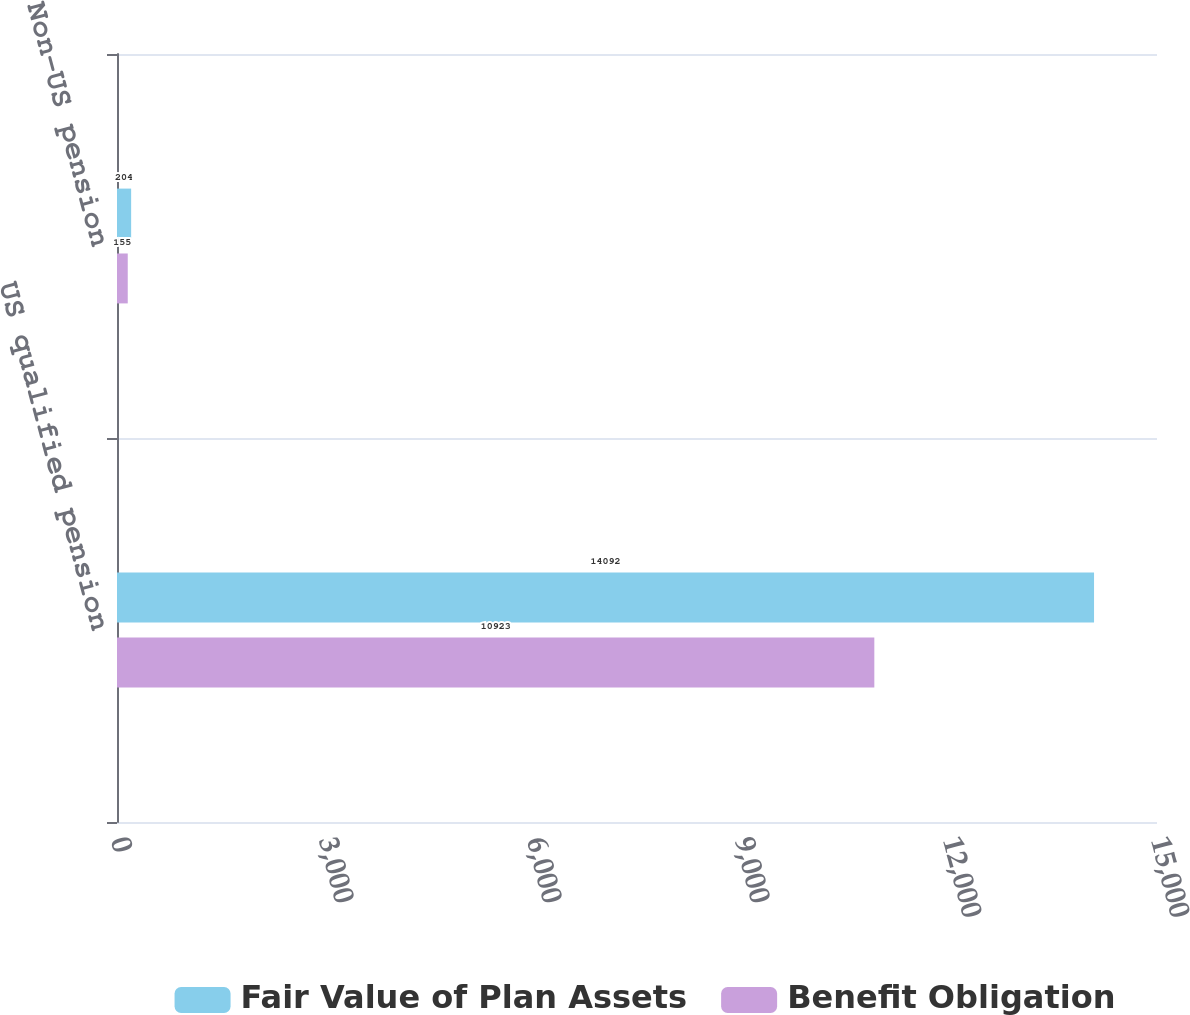<chart> <loc_0><loc_0><loc_500><loc_500><stacked_bar_chart><ecel><fcel>US qualified pension<fcel>Non-US pension<nl><fcel>Fair Value of Plan Assets<fcel>14092<fcel>204<nl><fcel>Benefit Obligation<fcel>10923<fcel>155<nl></chart> 